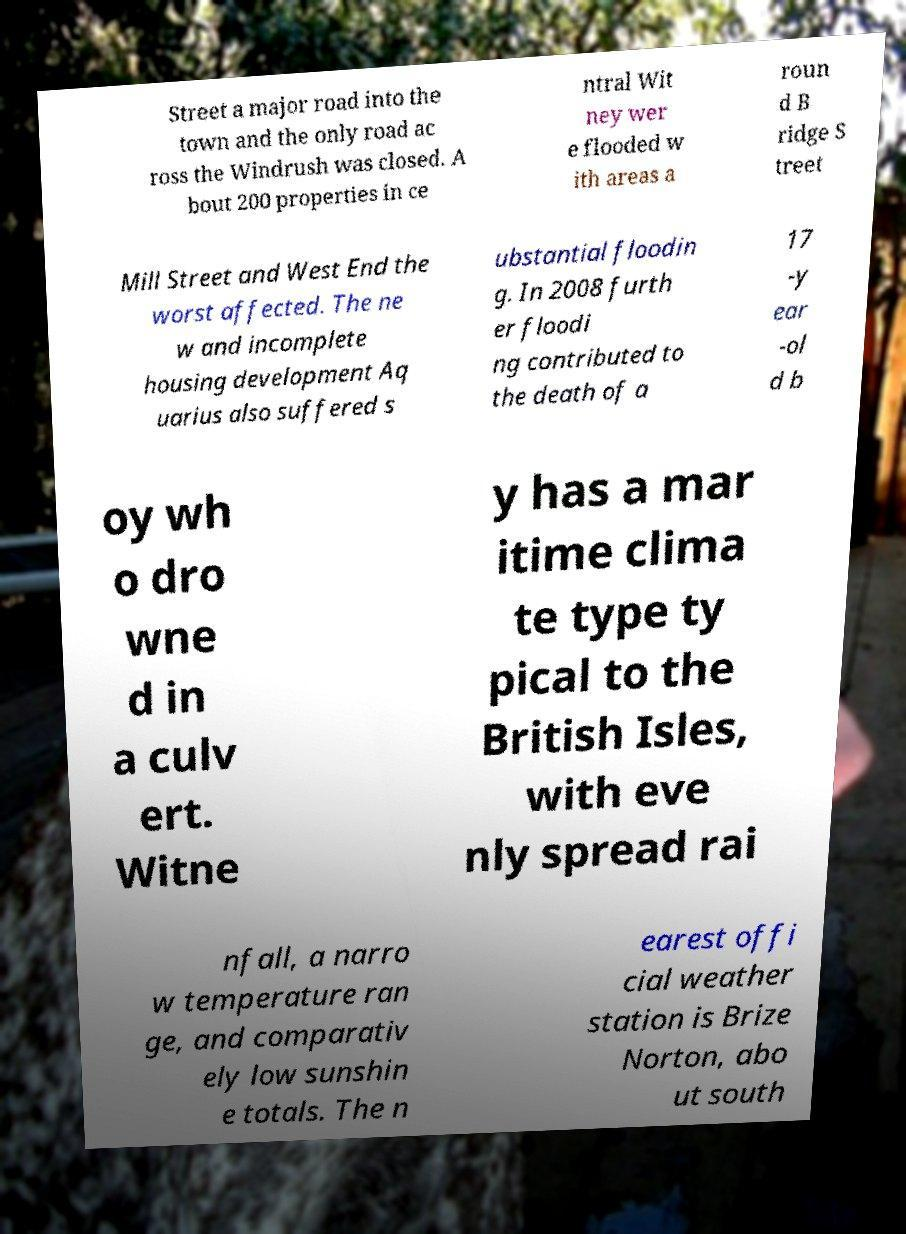There's text embedded in this image that I need extracted. Can you transcribe it verbatim? Street a major road into the town and the only road ac ross the Windrush was closed. A bout 200 properties in ce ntral Wit ney wer e flooded w ith areas a roun d B ridge S treet Mill Street and West End the worst affected. The ne w and incomplete housing development Aq uarius also suffered s ubstantial floodin g. In 2008 furth er floodi ng contributed to the death of a 17 -y ear -ol d b oy wh o dro wne d in a culv ert. Witne y has a mar itime clima te type ty pical to the British Isles, with eve nly spread rai nfall, a narro w temperature ran ge, and comparativ ely low sunshin e totals. The n earest offi cial weather station is Brize Norton, abo ut south 